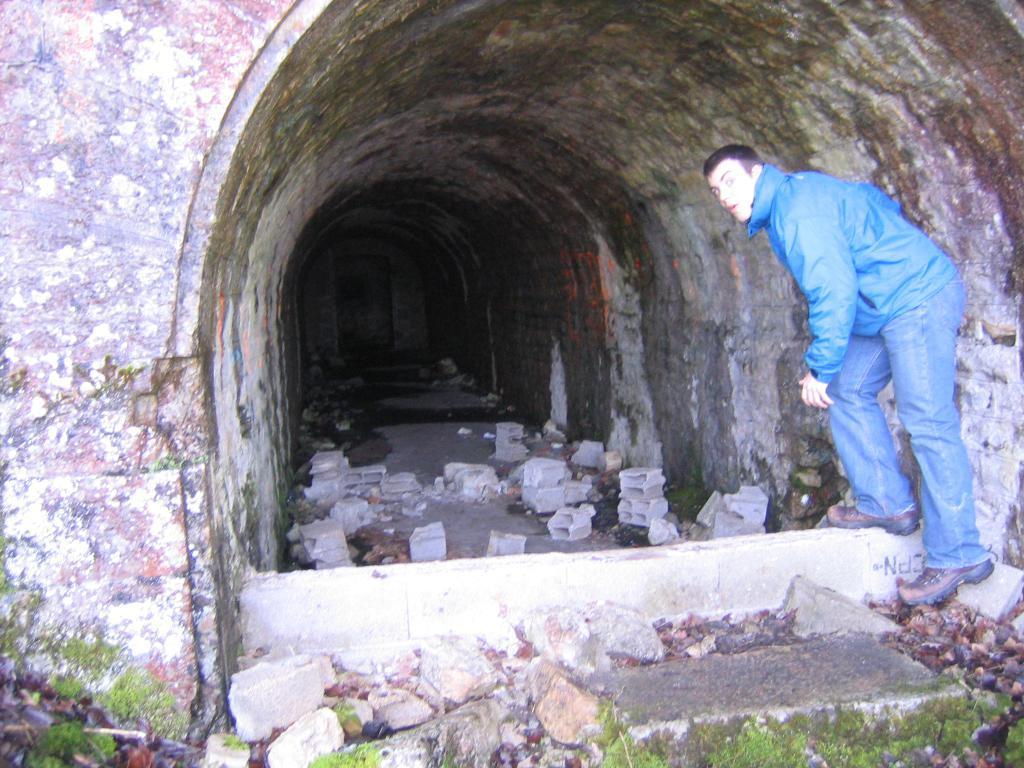Can you describe this image briefly? In this picture we can see a tunnel, man wore a jacket, shoes and standing, stones and grass on the ground. 